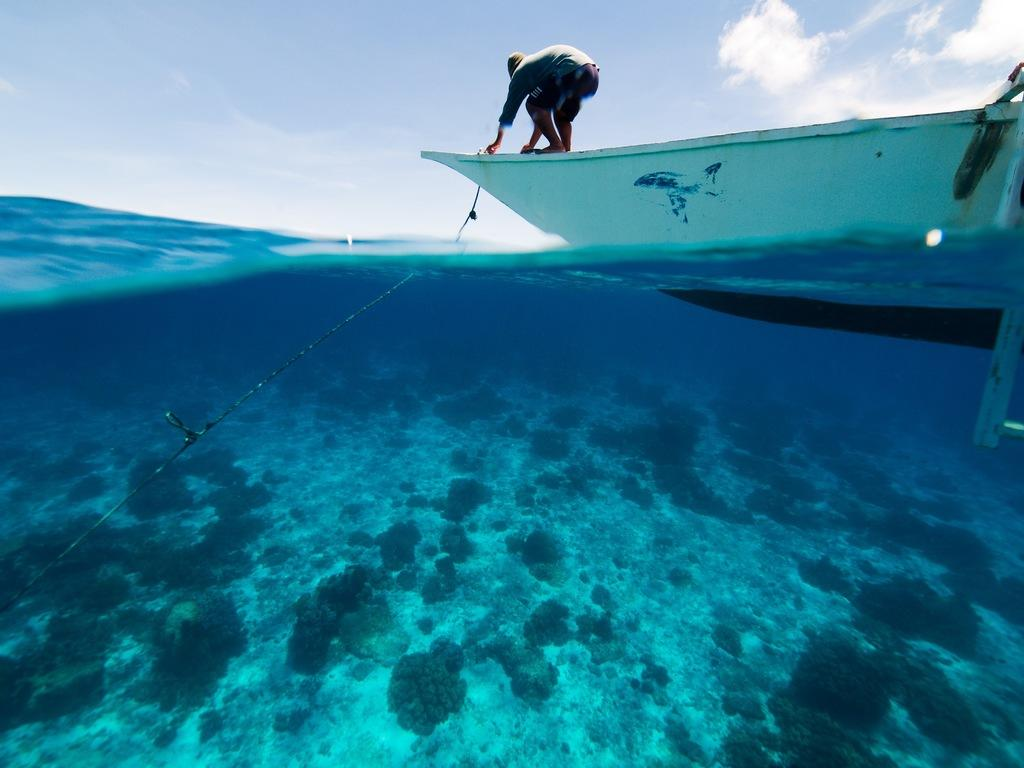What is the person in the image doing? The person is standing on a boat in the image. Where is the boat located? The boat is on the water. What can be seen under the water in the image? There are aquatic plants visible under the water. What is visible in the background of the image? The sky is visible in the background of the image. What type of disgust can be seen on the person's face in the image? There is no indication of disgust on the person's face in the image. What is the bone used for in the image? There is no bone present in the image. 